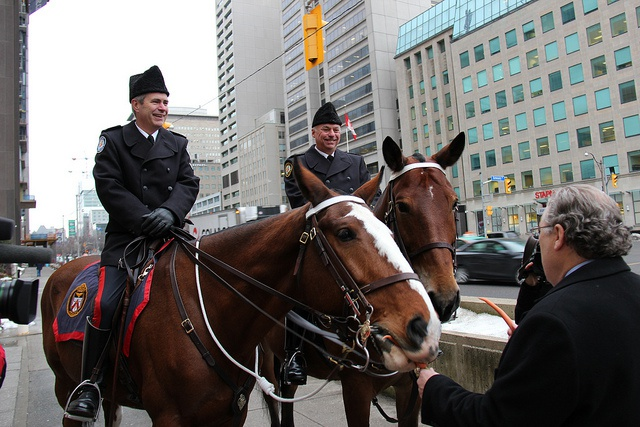Describe the objects in this image and their specific colors. I can see horse in gray, black, maroon, and white tones, people in gray, black, darkgray, and maroon tones, horse in gray, black, maroon, and brown tones, people in gray, black, and maroon tones, and people in gray, black, darkgray, and maroon tones in this image. 